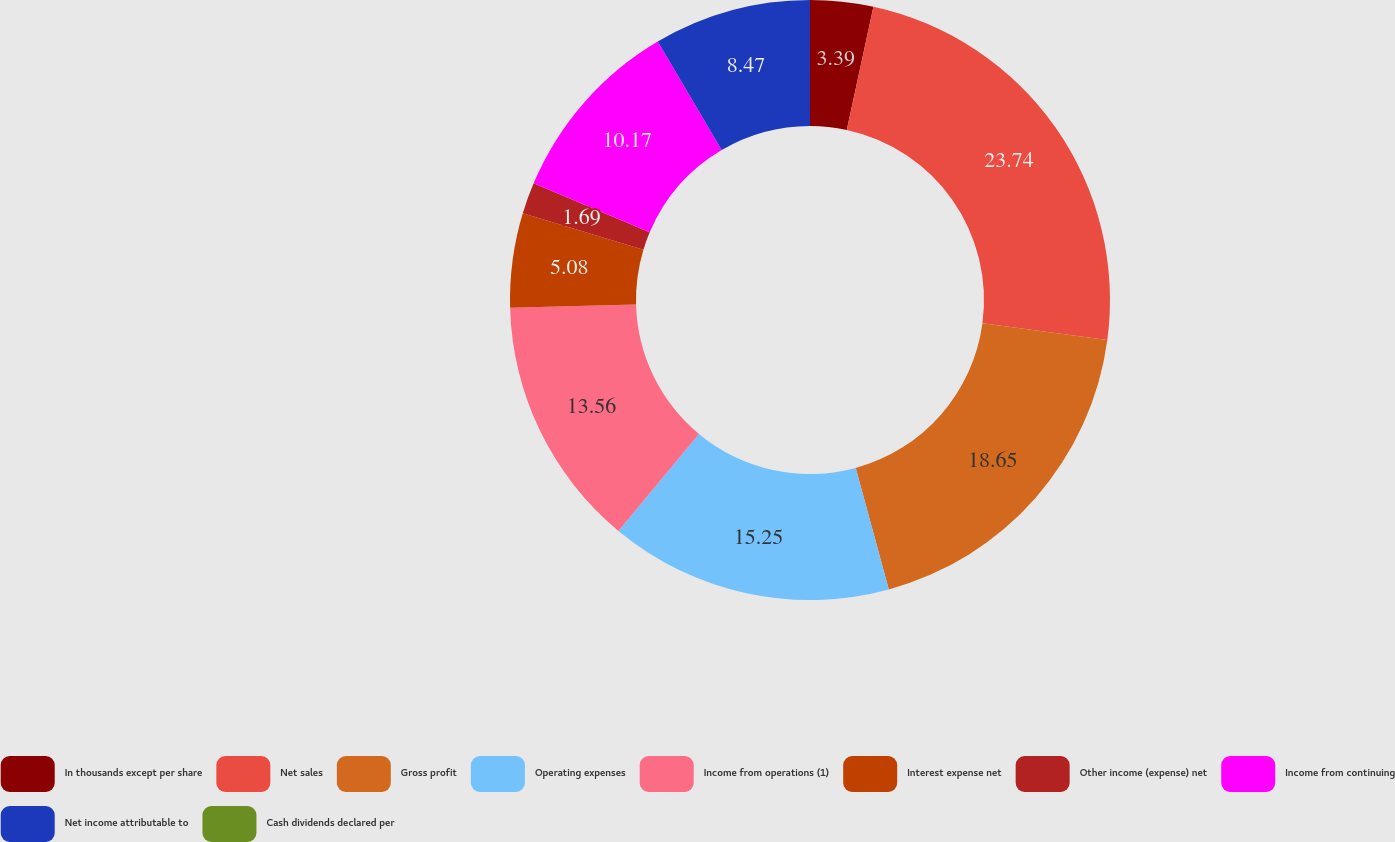Convert chart to OTSL. <chart><loc_0><loc_0><loc_500><loc_500><pie_chart><fcel>In thousands except per share<fcel>Net sales<fcel>Gross profit<fcel>Operating expenses<fcel>Income from operations (1)<fcel>Interest expense net<fcel>Other income (expense) net<fcel>Income from continuing<fcel>Net income attributable to<fcel>Cash dividends declared per<nl><fcel>3.39%<fcel>23.73%<fcel>18.64%<fcel>15.25%<fcel>13.56%<fcel>5.08%<fcel>1.69%<fcel>10.17%<fcel>8.47%<fcel>0.0%<nl></chart> 